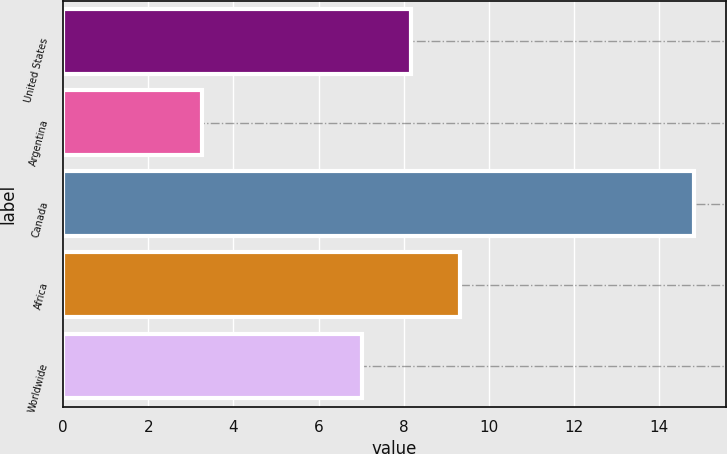Convert chart to OTSL. <chart><loc_0><loc_0><loc_500><loc_500><bar_chart><fcel>United States<fcel>Argentina<fcel>Canada<fcel>Africa<fcel>Worldwide<nl><fcel>8.17<fcel>3.26<fcel>14.83<fcel>9.33<fcel>7.01<nl></chart> 